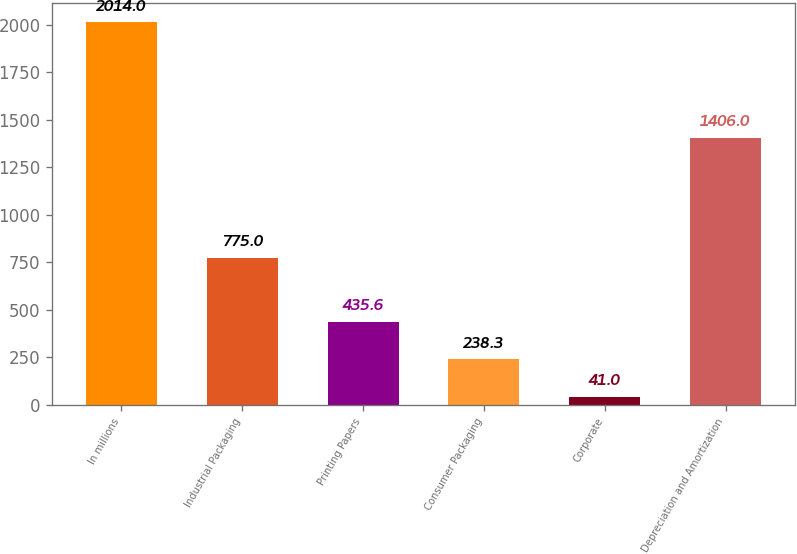Convert chart to OTSL. <chart><loc_0><loc_0><loc_500><loc_500><bar_chart><fcel>In millions<fcel>Industrial Packaging<fcel>Printing Papers<fcel>Consumer Packaging<fcel>Corporate<fcel>Depreciation and Amortization<nl><fcel>2014<fcel>775<fcel>435.6<fcel>238.3<fcel>41<fcel>1406<nl></chart> 